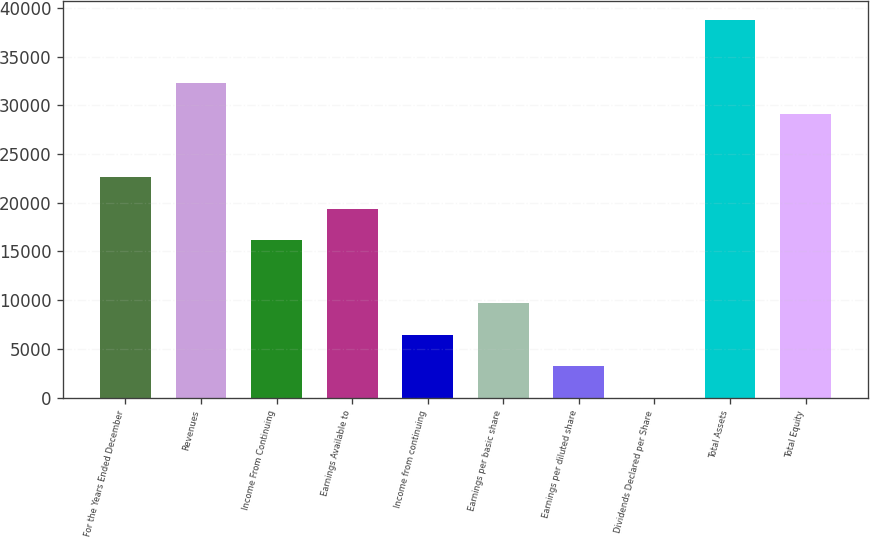Convert chart. <chart><loc_0><loc_0><loc_500><loc_500><bar_chart><fcel>For the Years Ended December<fcel>Revenues<fcel>Income From Continuing<fcel>Earnings Available to<fcel>Income from continuing<fcel>Earnings per basic share<fcel>Earnings per diluted share<fcel>Dividends Declared per Share<fcel>Total Assets<fcel>Total Equity<nl><fcel>22618.3<fcel>32311<fcel>16156.5<fcel>19387.4<fcel>6463.85<fcel>9694.75<fcel>3232.95<fcel>2.05<fcel>38772.8<fcel>29080.1<nl></chart> 